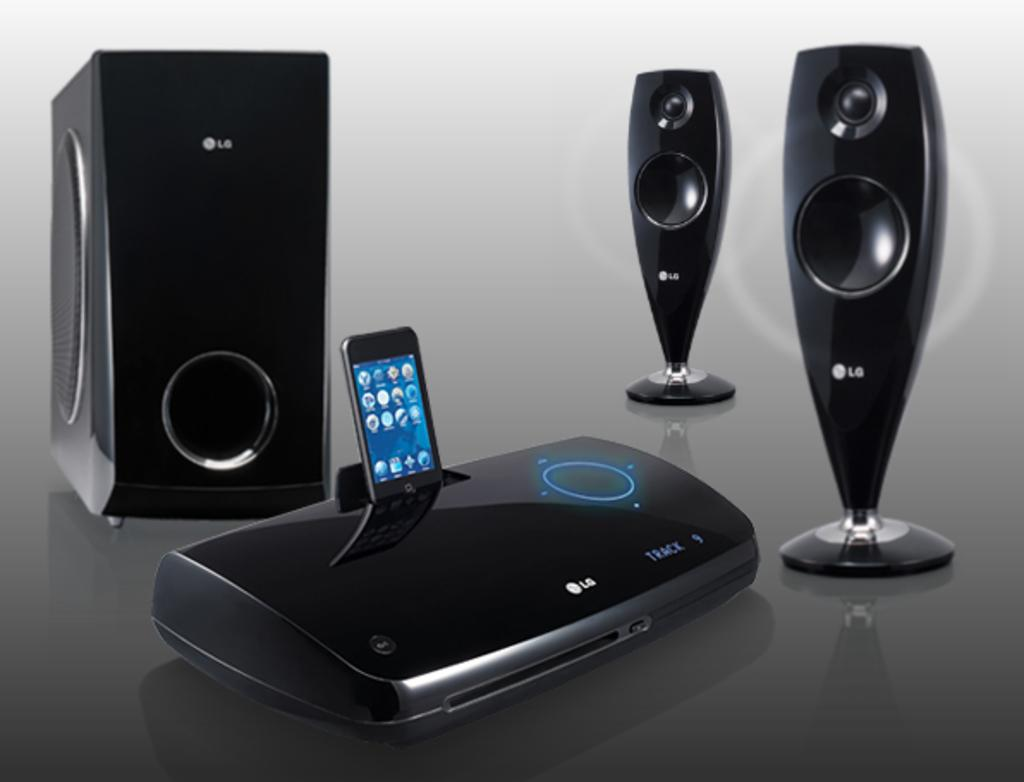<image>
Write a terse but informative summary of the picture. A black multimedia speaker system with a subwoofer made by LG. 